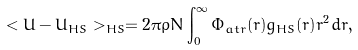<formula> <loc_0><loc_0><loc_500><loc_500>< U - U _ { H S } > _ { H S } = 2 \pi \rho N \int _ { 0 } ^ { \infty } \Phi _ { a t r } ( r ) g _ { H S } ( r ) r ^ { 2 } d r ,</formula> 